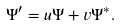Convert formula to latex. <formula><loc_0><loc_0><loc_500><loc_500>\Psi ^ { \prime } = u \Psi + v \Psi ^ { * } .</formula> 